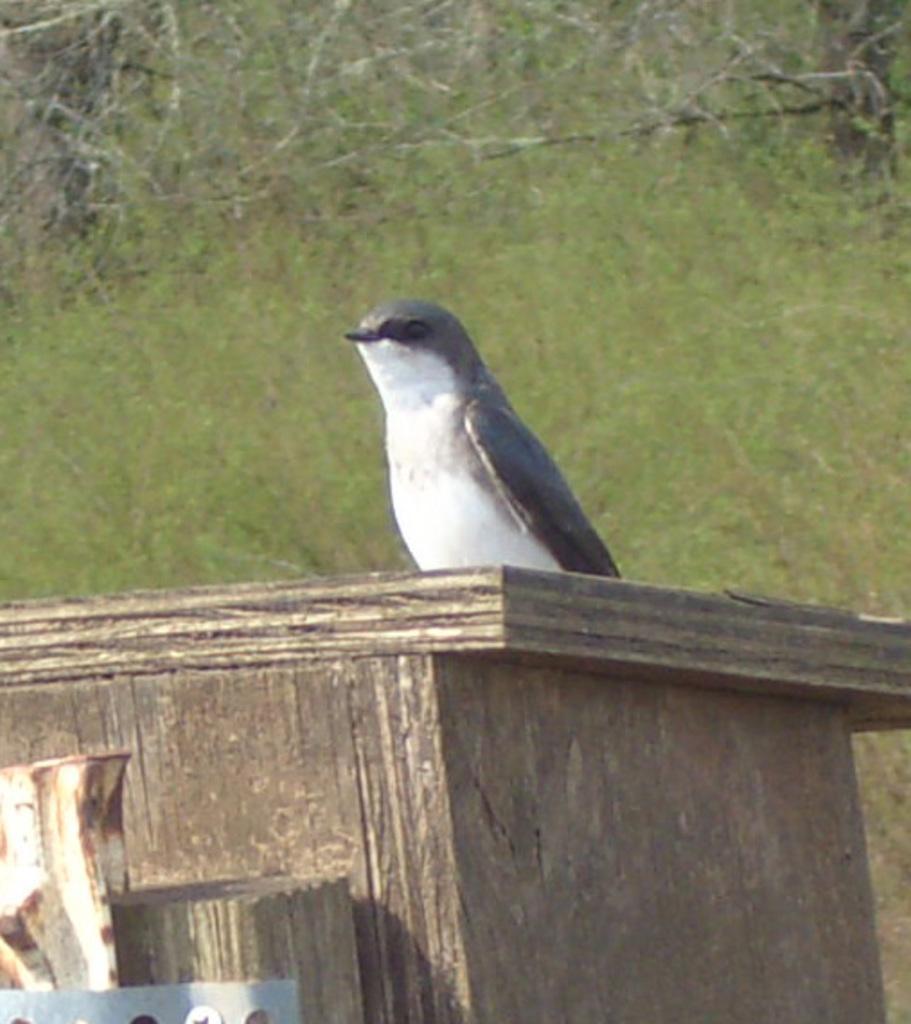Describe this image in one or two sentences. In this image I can see a bird on the wooden box. The bird is in white and grey color. Background is in green color. 